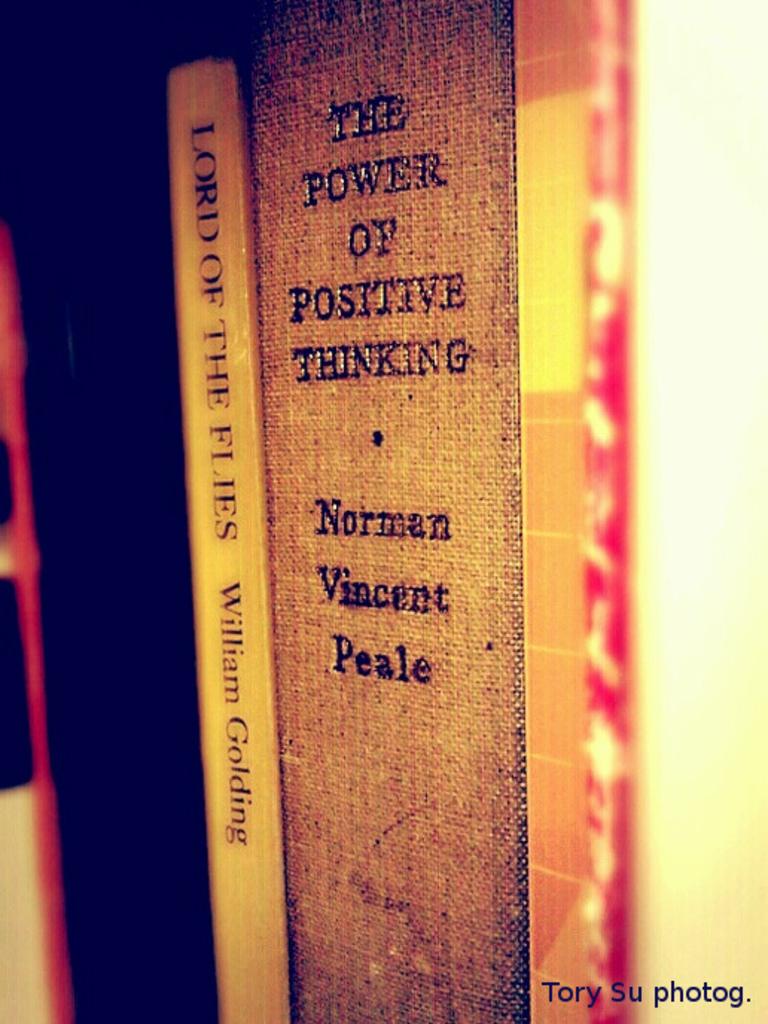What book is the large one?
Make the answer very short. The power of positive thinking. Who wrote the big book?
Ensure brevity in your answer.  Norman vincent peale. 